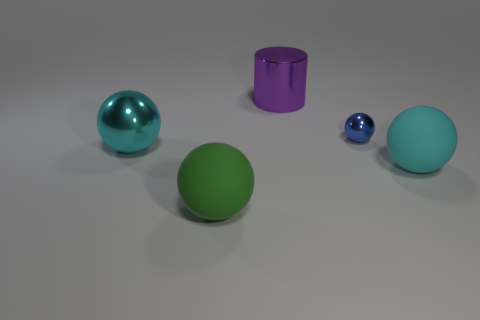Subtract 2 balls. How many balls are left? 2 Subtract all big balls. How many balls are left? 1 Add 1 big cyan metallic spheres. How many objects exist? 6 Subtract all brown balls. Subtract all purple blocks. How many balls are left? 4 Subtract all spheres. How many objects are left? 1 Subtract 0 red blocks. How many objects are left? 5 Subtract all green things. Subtract all blue spheres. How many objects are left? 3 Add 5 green objects. How many green objects are left? 6 Add 2 large cylinders. How many large cylinders exist? 3 